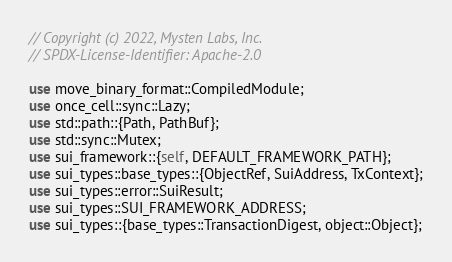<code> <loc_0><loc_0><loc_500><loc_500><_Rust_>// Copyright (c) 2022, Mysten Labs, Inc.
// SPDX-License-Identifier: Apache-2.0

use move_binary_format::CompiledModule;
use once_cell::sync::Lazy;
use std::path::{Path, PathBuf};
use std::sync::Mutex;
use sui_framework::{self, DEFAULT_FRAMEWORK_PATH};
use sui_types::base_types::{ObjectRef, SuiAddress, TxContext};
use sui_types::error::SuiResult;
use sui_types::SUI_FRAMEWORK_ADDRESS;
use sui_types::{base_types::TransactionDigest, object::Object};
</code> 